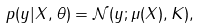<formula> <loc_0><loc_0><loc_500><loc_500>p ( y | X , \theta ) & = \mathcal { N } ( y ; \mathbb { \mu } ( X ) , K ) ,</formula> 